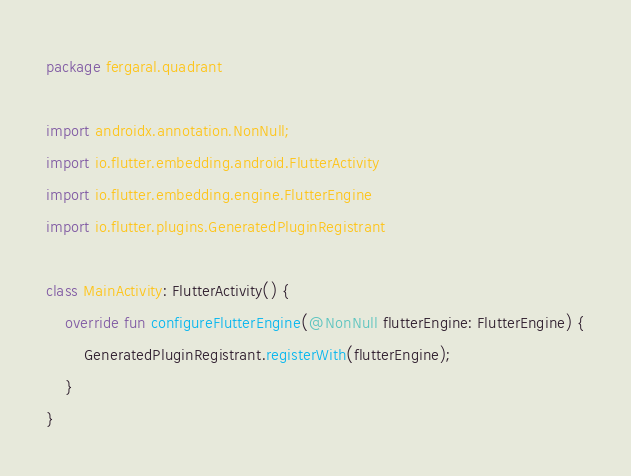Convert code to text. <code><loc_0><loc_0><loc_500><loc_500><_Kotlin_>package fergaral.quadrant

import androidx.annotation.NonNull;
import io.flutter.embedding.android.FlutterActivity
import io.flutter.embedding.engine.FlutterEngine
import io.flutter.plugins.GeneratedPluginRegistrant

class MainActivity: FlutterActivity() {
    override fun configureFlutterEngine(@NonNull flutterEngine: FlutterEngine) {
        GeneratedPluginRegistrant.registerWith(flutterEngine);
    }
}
</code> 